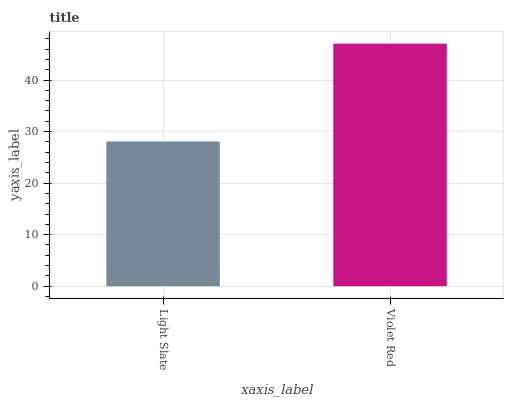Is Violet Red the maximum?
Answer yes or no. Yes. Is Violet Red the minimum?
Answer yes or no. No. Is Violet Red greater than Light Slate?
Answer yes or no. Yes. Is Light Slate less than Violet Red?
Answer yes or no. Yes. Is Light Slate greater than Violet Red?
Answer yes or no. No. Is Violet Red less than Light Slate?
Answer yes or no. No. Is Violet Red the high median?
Answer yes or no. Yes. Is Light Slate the low median?
Answer yes or no. Yes. Is Light Slate the high median?
Answer yes or no. No. Is Violet Red the low median?
Answer yes or no. No. 